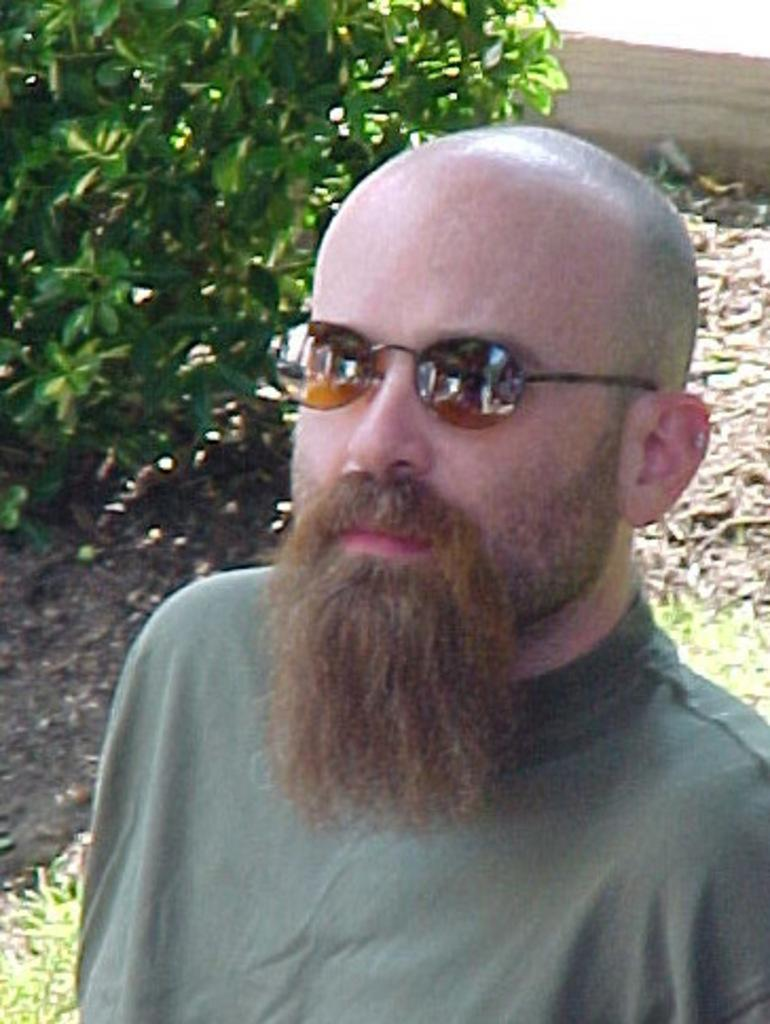Who is present in the image? There is a person in the image. What accessory is the person wearing? The person is wearing glasses. What can be seen in the background of the image? There is a tree in the background of the image. How many children are playing with the pan in the image? There are no children or pans present in the image. What is the nationality of the person in the image? The nationality of the person in the image cannot be determined from the image alone. 